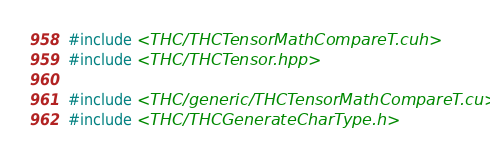Convert code to text. <code><loc_0><loc_0><loc_500><loc_500><_Cuda_>#include <THC/THCTensorMathCompareT.cuh>
#include <THC/THCTensor.hpp>

#include <THC/generic/THCTensorMathCompareT.cu>
#include <THC/THCGenerateCharType.h>
</code> 